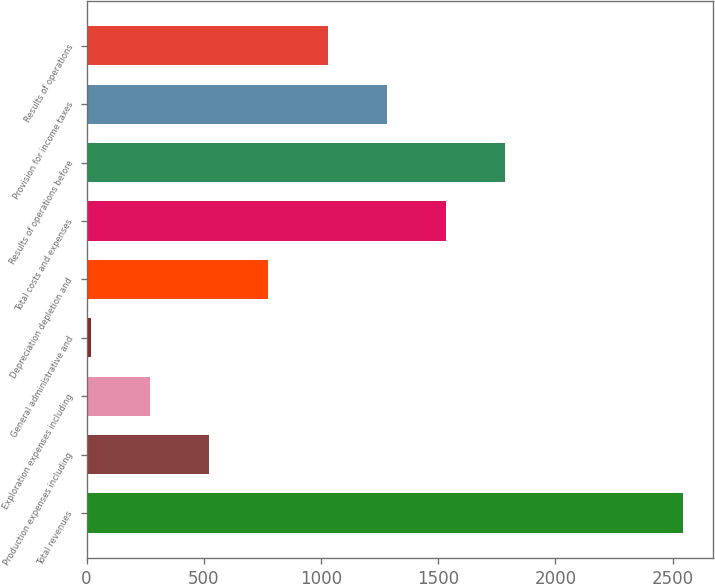Convert chart. <chart><loc_0><loc_0><loc_500><loc_500><bar_chart><fcel>Total revenues<fcel>Production expenses including<fcel>Exploration expenses including<fcel>General administrative and<fcel>Depreciation depletion and<fcel>Total costs and expenses<fcel>Results of operations before<fcel>Provision for income taxes<fcel>Results of operations<nl><fcel>2545<fcel>522.6<fcel>269.8<fcel>17<fcel>775.4<fcel>1533.8<fcel>1786.6<fcel>1281<fcel>1028.2<nl></chart> 